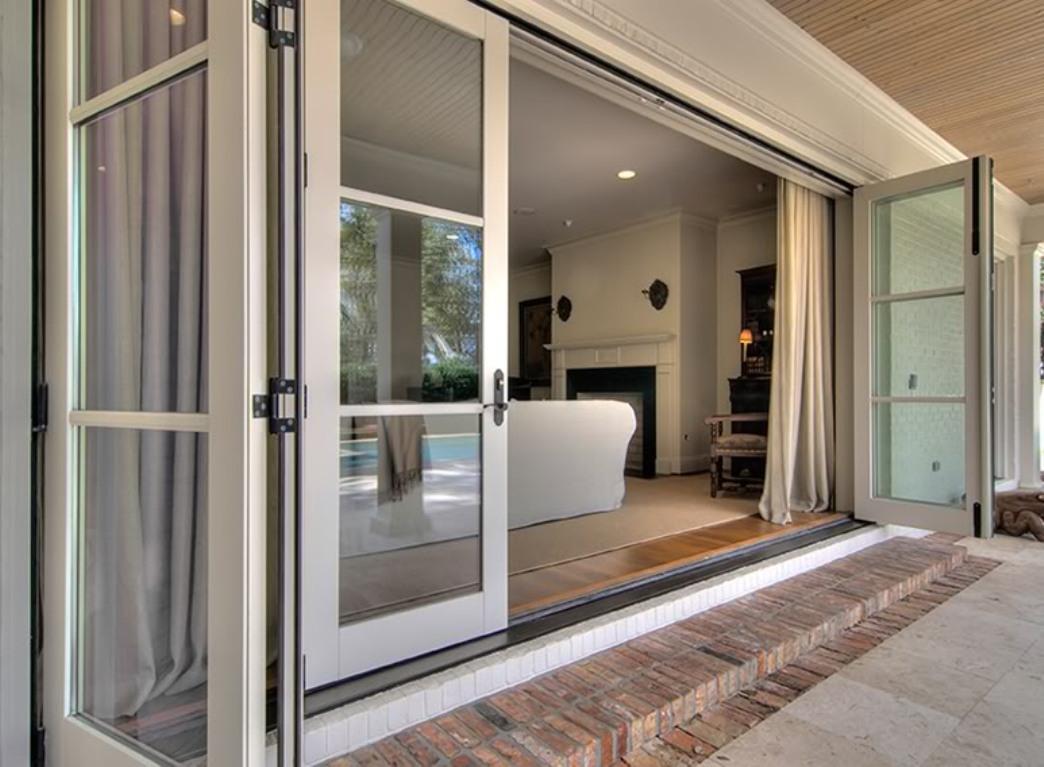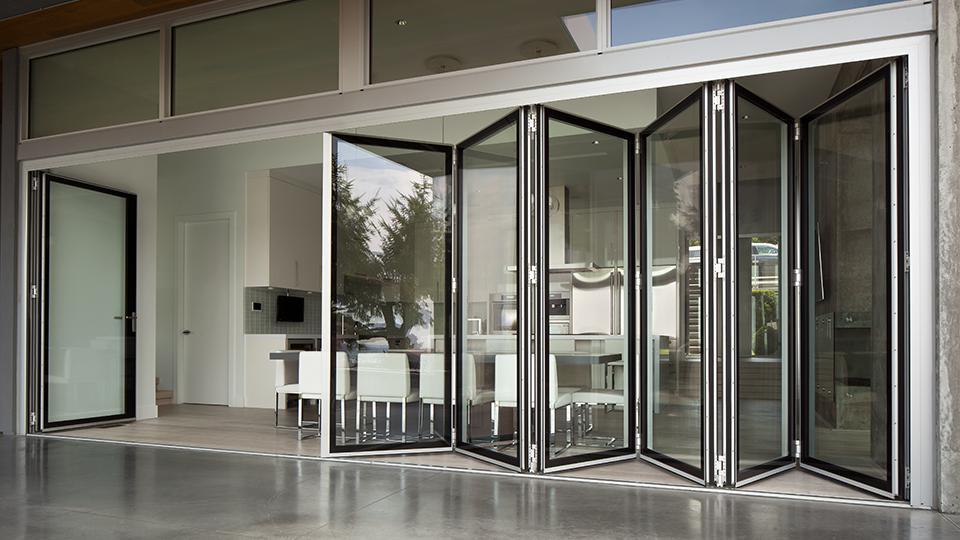The first image is the image on the left, the second image is the image on the right. Analyze the images presented: Is the assertion "There are two glass door with multiple panes that reveal grass and foliage in the backyard." valid? Answer yes or no. No. The first image is the image on the left, the second image is the image on the right. For the images shown, is this caption "One image is looking in a wide open door from the outside." true? Answer yes or no. Yes. 